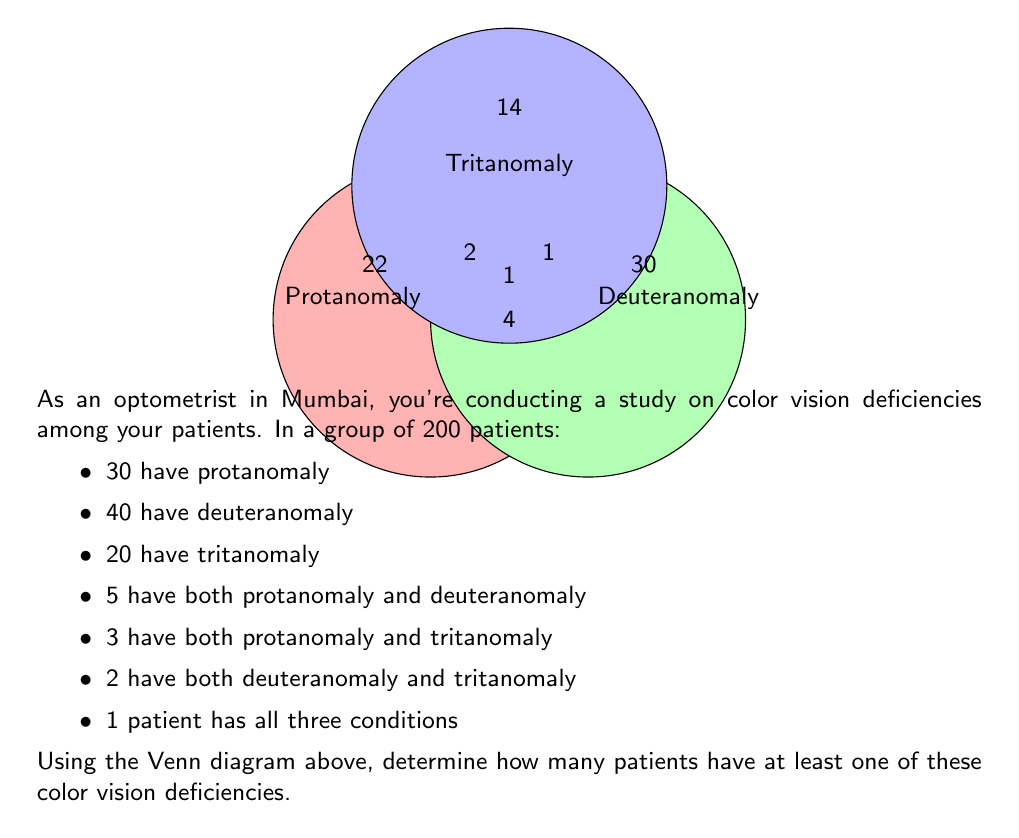Help me with this question. Let's approach this step-by-step using the given information and the principles of set theory:

1) First, we need to identify the number of patients in each distinct region of the Venn diagram:

   - Patients with only protanomaly: 30 - 5 - 3 + 1 = 23
   - Patients with only deuteranomaly: 40 - 5 - 2 + 1 = 34
   - Patients with only tritanomaly: 20 - 3 - 2 + 1 = 16
   - Patients with protanomaly and deuteranomaly only: 5 - 1 = 4
   - Patients with protanomaly and tritanomaly only: 3 - 1 = 2
   - Patients with deuteranomaly and tritanomaly only: 2 - 1 = 1
   - Patients with all three conditions: 1

2) Now, we can sum up all these distinct groups:

   $23 + 34 + 16 + 4 + 2 + 1 + 1 = 81$

3) To verify, we can use the principle of inclusion-exclusion:

   $|A \cup B \cup C| = |A| + |B| + |C| - |A \cap B| - |A \cap C| - |B \cap C| + |A \cap B \cap C|$

   Where A = Protanomaly, B = Deuteranomaly, C = Tritanomaly

   $81 = 30 + 40 + 20 - 5 - 3 - 2 + 1$

   $81 = 81$

Therefore, 81 patients have at least one of these color vision deficiencies.
Answer: 81 patients 